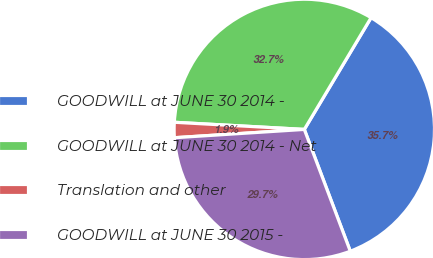Convert chart. <chart><loc_0><loc_0><loc_500><loc_500><pie_chart><fcel>GOODWILL at JUNE 30 2014 -<fcel>GOODWILL at JUNE 30 2014 - Net<fcel>Translation and other<fcel>GOODWILL at JUNE 30 2015 -<nl><fcel>35.68%<fcel>32.7%<fcel>1.89%<fcel>29.73%<nl></chart> 